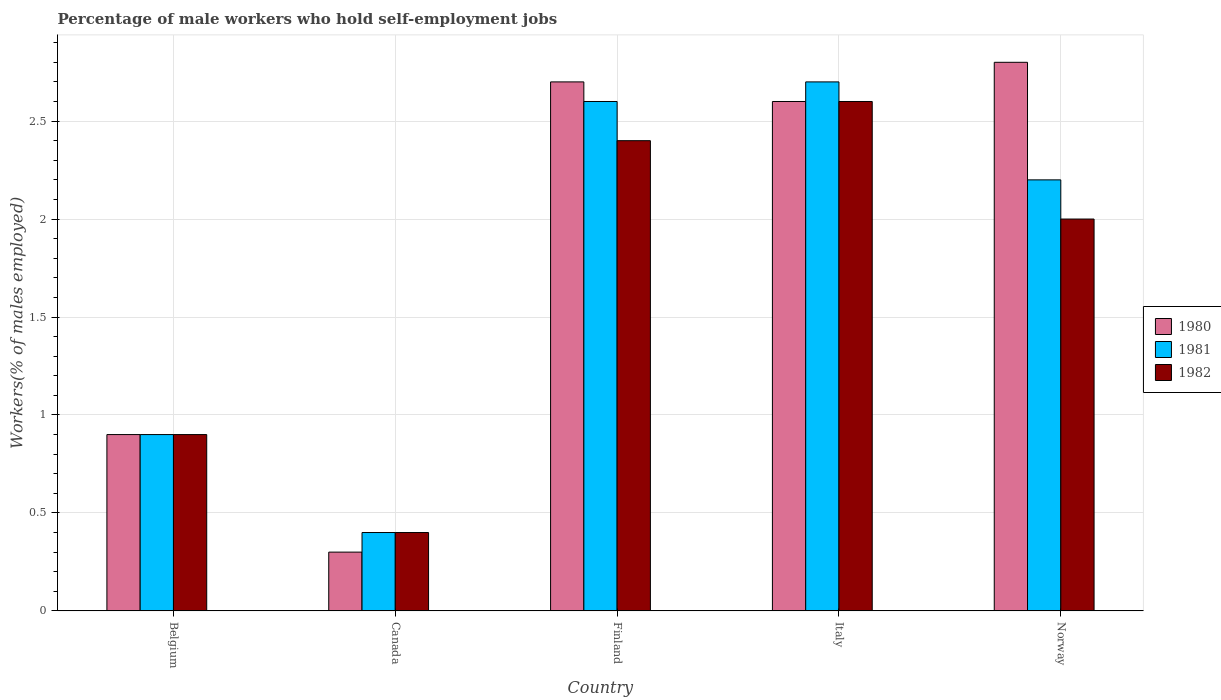How many different coloured bars are there?
Your response must be concise. 3. What is the percentage of self-employed male workers in 1982 in Canada?
Your response must be concise. 0.4. Across all countries, what is the maximum percentage of self-employed male workers in 1981?
Keep it short and to the point. 2.7. Across all countries, what is the minimum percentage of self-employed male workers in 1982?
Your response must be concise. 0.4. In which country was the percentage of self-employed male workers in 1982 maximum?
Ensure brevity in your answer.  Italy. What is the total percentage of self-employed male workers in 1981 in the graph?
Make the answer very short. 8.8. What is the difference between the percentage of self-employed male workers in 1982 in Belgium and that in Finland?
Make the answer very short. -1.5. What is the difference between the percentage of self-employed male workers in 1980 in Belgium and the percentage of self-employed male workers in 1982 in Italy?
Your answer should be very brief. -1.7. What is the average percentage of self-employed male workers in 1982 per country?
Your answer should be compact. 1.66. What is the difference between the percentage of self-employed male workers of/in 1981 and percentage of self-employed male workers of/in 1980 in Finland?
Offer a terse response. -0.1. In how many countries, is the percentage of self-employed male workers in 1982 greater than 2.1 %?
Offer a very short reply. 2. What is the ratio of the percentage of self-employed male workers in 1980 in Belgium to that in Italy?
Your answer should be compact. 0.35. What is the difference between the highest and the second highest percentage of self-employed male workers in 1980?
Keep it short and to the point. 0.1. What is the difference between the highest and the lowest percentage of self-employed male workers in 1980?
Offer a terse response. 2.5. In how many countries, is the percentage of self-employed male workers in 1982 greater than the average percentage of self-employed male workers in 1982 taken over all countries?
Offer a very short reply. 3. What does the 3rd bar from the left in Belgium represents?
Your answer should be very brief. 1982. Is it the case that in every country, the sum of the percentage of self-employed male workers in 1982 and percentage of self-employed male workers in 1981 is greater than the percentage of self-employed male workers in 1980?
Keep it short and to the point. Yes. How many bars are there?
Give a very brief answer. 15. What is the difference between two consecutive major ticks on the Y-axis?
Give a very brief answer. 0.5. Does the graph contain any zero values?
Your answer should be very brief. No. Does the graph contain grids?
Provide a short and direct response. Yes. Where does the legend appear in the graph?
Your response must be concise. Center right. What is the title of the graph?
Provide a succinct answer. Percentage of male workers who hold self-employment jobs. Does "1972" appear as one of the legend labels in the graph?
Your answer should be compact. No. What is the label or title of the Y-axis?
Provide a succinct answer. Workers(% of males employed). What is the Workers(% of males employed) in 1980 in Belgium?
Your answer should be compact. 0.9. What is the Workers(% of males employed) of 1981 in Belgium?
Your response must be concise. 0.9. What is the Workers(% of males employed) in 1982 in Belgium?
Give a very brief answer. 0.9. What is the Workers(% of males employed) in 1980 in Canada?
Keep it short and to the point. 0.3. What is the Workers(% of males employed) of 1981 in Canada?
Your response must be concise. 0.4. What is the Workers(% of males employed) of 1982 in Canada?
Your response must be concise. 0.4. What is the Workers(% of males employed) of 1980 in Finland?
Your response must be concise. 2.7. What is the Workers(% of males employed) in 1981 in Finland?
Keep it short and to the point. 2.6. What is the Workers(% of males employed) of 1982 in Finland?
Keep it short and to the point. 2.4. What is the Workers(% of males employed) of 1980 in Italy?
Keep it short and to the point. 2.6. What is the Workers(% of males employed) in 1981 in Italy?
Keep it short and to the point. 2.7. What is the Workers(% of males employed) of 1982 in Italy?
Your answer should be compact. 2.6. What is the Workers(% of males employed) of 1980 in Norway?
Your answer should be very brief. 2.8. What is the Workers(% of males employed) of 1981 in Norway?
Your answer should be very brief. 2.2. What is the Workers(% of males employed) of 1982 in Norway?
Make the answer very short. 2. Across all countries, what is the maximum Workers(% of males employed) in 1980?
Make the answer very short. 2.8. Across all countries, what is the maximum Workers(% of males employed) of 1981?
Provide a short and direct response. 2.7. Across all countries, what is the maximum Workers(% of males employed) in 1982?
Provide a short and direct response. 2.6. Across all countries, what is the minimum Workers(% of males employed) in 1980?
Your answer should be very brief. 0.3. Across all countries, what is the minimum Workers(% of males employed) in 1981?
Your answer should be very brief. 0.4. Across all countries, what is the minimum Workers(% of males employed) of 1982?
Provide a succinct answer. 0.4. What is the total Workers(% of males employed) in 1980 in the graph?
Offer a terse response. 9.3. What is the total Workers(% of males employed) of 1982 in the graph?
Your answer should be compact. 8.3. What is the difference between the Workers(% of males employed) of 1982 in Belgium and that in Canada?
Offer a very short reply. 0.5. What is the difference between the Workers(% of males employed) of 1980 in Belgium and that in Finland?
Give a very brief answer. -1.8. What is the difference between the Workers(% of males employed) of 1981 in Belgium and that in Finland?
Ensure brevity in your answer.  -1.7. What is the difference between the Workers(% of males employed) of 1982 in Canada and that in Finland?
Offer a very short reply. -2. What is the difference between the Workers(% of males employed) of 1981 in Canada and that in Italy?
Provide a short and direct response. -2.3. What is the difference between the Workers(% of males employed) of 1982 in Canada and that in Italy?
Your answer should be compact. -2.2. What is the difference between the Workers(% of males employed) of 1981 in Finland and that in Italy?
Your answer should be compact. -0.1. What is the difference between the Workers(% of males employed) of 1982 in Finland and that in Italy?
Offer a very short reply. -0.2. What is the difference between the Workers(% of males employed) of 1981 in Finland and that in Norway?
Your answer should be compact. 0.4. What is the difference between the Workers(% of males employed) in 1980 in Italy and that in Norway?
Give a very brief answer. -0.2. What is the difference between the Workers(% of males employed) of 1981 in Italy and that in Norway?
Keep it short and to the point. 0.5. What is the difference between the Workers(% of males employed) of 1982 in Italy and that in Norway?
Offer a very short reply. 0.6. What is the difference between the Workers(% of males employed) in 1980 in Belgium and the Workers(% of males employed) in 1981 in Canada?
Make the answer very short. 0.5. What is the difference between the Workers(% of males employed) of 1980 in Belgium and the Workers(% of males employed) of 1982 in Canada?
Your answer should be very brief. 0.5. What is the difference between the Workers(% of males employed) of 1981 in Belgium and the Workers(% of males employed) of 1982 in Canada?
Your answer should be very brief. 0.5. What is the difference between the Workers(% of males employed) in 1980 in Belgium and the Workers(% of males employed) in 1982 in Finland?
Your response must be concise. -1.5. What is the difference between the Workers(% of males employed) of 1980 in Belgium and the Workers(% of males employed) of 1982 in Italy?
Offer a very short reply. -1.7. What is the difference between the Workers(% of males employed) in 1981 in Belgium and the Workers(% of males employed) in 1982 in Italy?
Provide a succinct answer. -1.7. What is the difference between the Workers(% of males employed) of 1980 in Belgium and the Workers(% of males employed) of 1981 in Norway?
Your answer should be very brief. -1.3. What is the difference between the Workers(% of males employed) in 1980 in Canada and the Workers(% of males employed) in 1981 in Finland?
Your response must be concise. -2.3. What is the difference between the Workers(% of males employed) in 1981 in Canada and the Workers(% of males employed) in 1982 in Italy?
Provide a short and direct response. -2.2. What is the difference between the Workers(% of males employed) in 1980 in Canada and the Workers(% of males employed) in 1981 in Norway?
Your response must be concise. -1.9. What is the difference between the Workers(% of males employed) of 1980 in Canada and the Workers(% of males employed) of 1982 in Norway?
Your answer should be very brief. -1.7. What is the difference between the Workers(% of males employed) of 1981 in Canada and the Workers(% of males employed) of 1982 in Norway?
Provide a short and direct response. -1.6. What is the difference between the Workers(% of males employed) of 1981 in Finland and the Workers(% of males employed) of 1982 in Italy?
Your answer should be compact. 0. What is the difference between the Workers(% of males employed) in 1980 in Finland and the Workers(% of males employed) in 1981 in Norway?
Offer a very short reply. 0.5. What is the difference between the Workers(% of males employed) of 1981 in Finland and the Workers(% of males employed) of 1982 in Norway?
Offer a terse response. 0.6. What is the difference between the Workers(% of males employed) of 1980 in Italy and the Workers(% of males employed) of 1981 in Norway?
Your answer should be very brief. 0.4. What is the difference between the Workers(% of males employed) in 1980 in Italy and the Workers(% of males employed) in 1982 in Norway?
Make the answer very short. 0.6. What is the average Workers(% of males employed) in 1980 per country?
Your response must be concise. 1.86. What is the average Workers(% of males employed) in 1981 per country?
Your answer should be very brief. 1.76. What is the average Workers(% of males employed) of 1982 per country?
Your response must be concise. 1.66. What is the difference between the Workers(% of males employed) of 1980 and Workers(% of males employed) of 1982 in Canada?
Your answer should be compact. -0.1. What is the difference between the Workers(% of males employed) of 1980 and Workers(% of males employed) of 1981 in Finland?
Keep it short and to the point. 0.1. What is the difference between the Workers(% of males employed) of 1980 and Workers(% of males employed) of 1982 in Finland?
Provide a short and direct response. 0.3. What is the difference between the Workers(% of males employed) of 1981 and Workers(% of males employed) of 1982 in Finland?
Offer a terse response. 0.2. What is the difference between the Workers(% of males employed) in 1980 and Workers(% of males employed) in 1982 in Italy?
Ensure brevity in your answer.  0. What is the difference between the Workers(% of males employed) of 1981 and Workers(% of males employed) of 1982 in Italy?
Provide a short and direct response. 0.1. What is the difference between the Workers(% of males employed) in 1980 and Workers(% of males employed) in 1982 in Norway?
Your response must be concise. 0.8. What is the ratio of the Workers(% of males employed) in 1981 in Belgium to that in Canada?
Offer a very short reply. 2.25. What is the ratio of the Workers(% of males employed) of 1982 in Belgium to that in Canada?
Give a very brief answer. 2.25. What is the ratio of the Workers(% of males employed) of 1980 in Belgium to that in Finland?
Your response must be concise. 0.33. What is the ratio of the Workers(% of males employed) of 1981 in Belgium to that in Finland?
Make the answer very short. 0.35. What is the ratio of the Workers(% of males employed) of 1980 in Belgium to that in Italy?
Give a very brief answer. 0.35. What is the ratio of the Workers(% of males employed) in 1981 in Belgium to that in Italy?
Provide a short and direct response. 0.33. What is the ratio of the Workers(% of males employed) of 1982 in Belgium to that in Italy?
Provide a short and direct response. 0.35. What is the ratio of the Workers(% of males employed) in 1980 in Belgium to that in Norway?
Offer a very short reply. 0.32. What is the ratio of the Workers(% of males employed) of 1981 in Belgium to that in Norway?
Keep it short and to the point. 0.41. What is the ratio of the Workers(% of males employed) in 1982 in Belgium to that in Norway?
Provide a short and direct response. 0.45. What is the ratio of the Workers(% of males employed) in 1981 in Canada to that in Finland?
Make the answer very short. 0.15. What is the ratio of the Workers(% of males employed) in 1982 in Canada to that in Finland?
Provide a short and direct response. 0.17. What is the ratio of the Workers(% of males employed) in 1980 in Canada to that in Italy?
Keep it short and to the point. 0.12. What is the ratio of the Workers(% of males employed) in 1981 in Canada to that in Italy?
Your answer should be compact. 0.15. What is the ratio of the Workers(% of males employed) in 1982 in Canada to that in Italy?
Provide a short and direct response. 0.15. What is the ratio of the Workers(% of males employed) in 1980 in Canada to that in Norway?
Give a very brief answer. 0.11. What is the ratio of the Workers(% of males employed) in 1981 in Canada to that in Norway?
Provide a short and direct response. 0.18. What is the ratio of the Workers(% of males employed) in 1980 in Finland to that in Norway?
Ensure brevity in your answer.  0.96. What is the ratio of the Workers(% of males employed) in 1981 in Finland to that in Norway?
Your response must be concise. 1.18. What is the ratio of the Workers(% of males employed) in 1980 in Italy to that in Norway?
Ensure brevity in your answer.  0.93. What is the ratio of the Workers(% of males employed) of 1981 in Italy to that in Norway?
Provide a short and direct response. 1.23. What is the difference between the highest and the second highest Workers(% of males employed) of 1980?
Offer a terse response. 0.1. What is the difference between the highest and the second highest Workers(% of males employed) of 1981?
Keep it short and to the point. 0.1. What is the difference between the highest and the lowest Workers(% of males employed) of 1981?
Give a very brief answer. 2.3. What is the difference between the highest and the lowest Workers(% of males employed) in 1982?
Provide a succinct answer. 2.2. 